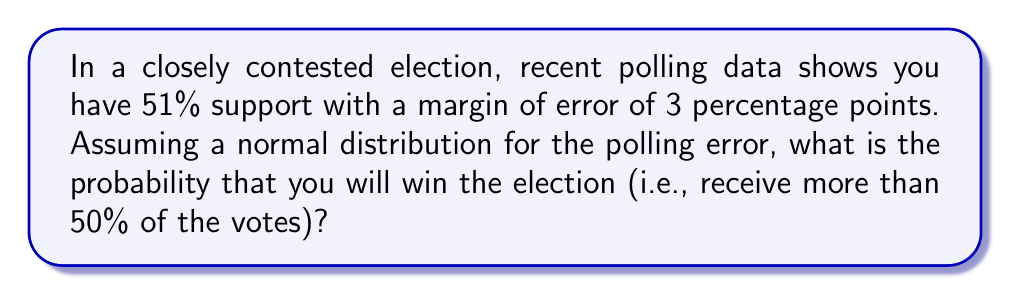Can you answer this question? To solve this problem, we'll follow these steps:

1) First, we need to understand that the margin of error represents the standard deviation of the polling results. In this case, it's 3 percentage points.

2) We want to find the probability of receiving more than 50% of the votes, given that the poll shows 51% support.

3) We can use the standard normal distribution (z-score) to calculate this probability. The z-score formula is:

   $$z = \frac{x - \mu}{\sigma}$$

   Where:
   $x$ is the value we're interested in (50% in this case)
   $\mu$ is the mean (51% from the poll)
   $\sigma$ is the standard deviation (3% margin of error)

4) Plugging in our values:

   $$z = \frac{50 - 51}{3} = -\frac{1}{3} \approx -0.33$$

5) Now, we need to find the probability that z is greater than -0.33. This is equivalent to finding the area under the standard normal curve to the right of -0.33.

6) Using a standard normal table or calculator, we can find that:

   $$P(Z > -0.33) \approx 0.6293$$

7) Therefore, the probability of winning the election (receiving more than 50% of the votes) is approximately 0.6293 or 62.93%.
Answer: $\approx 0.6293$ or $62.93\%$ 